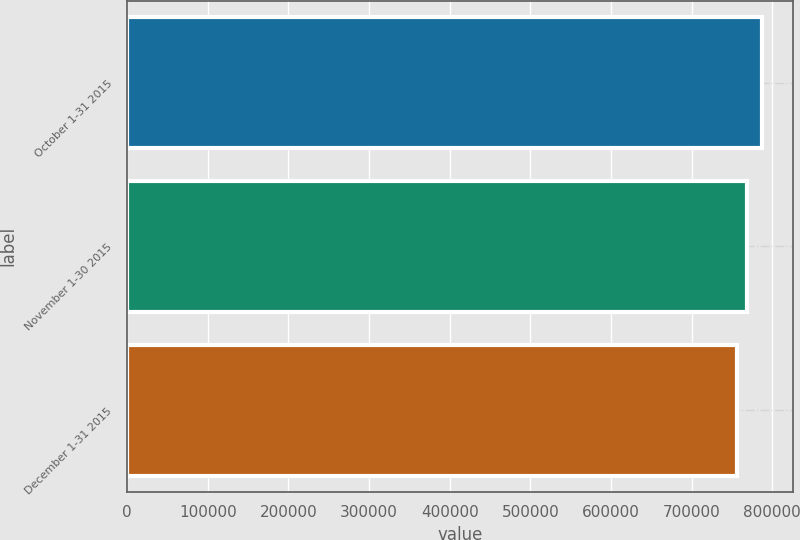Convert chart to OTSL. <chart><loc_0><loc_0><loc_500><loc_500><bar_chart><fcel>October 1-31 2015<fcel>November 1-30 2015<fcel>December 1-31 2015<nl><fcel>786625<fcel>768226<fcel>755864<nl></chart> 